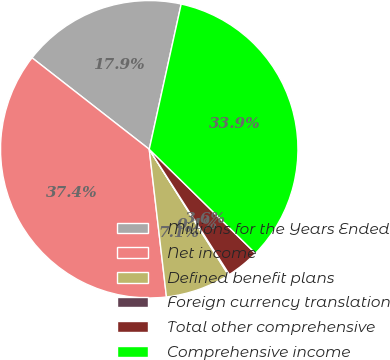Convert chart to OTSL. <chart><loc_0><loc_0><loc_500><loc_500><pie_chart><fcel>Millions for the Years Ended<fcel>Net income<fcel>Defined benefit plans<fcel>Foreign currency translation<fcel>Total other comprehensive<fcel>Comprehensive income<nl><fcel>17.9%<fcel>37.4%<fcel>7.1%<fcel>0.11%<fcel>3.6%<fcel>33.9%<nl></chart> 